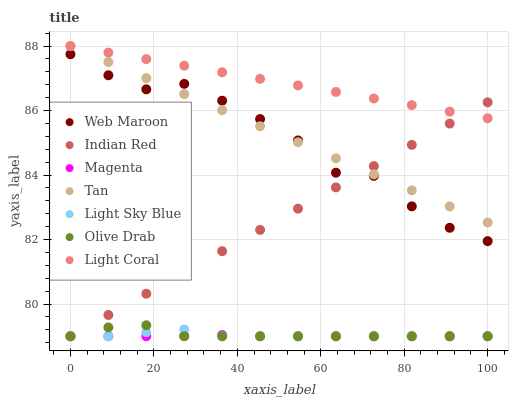Does Magenta have the minimum area under the curve?
Answer yes or no. Yes. Does Light Coral have the maximum area under the curve?
Answer yes or no. Yes. Does Light Sky Blue have the minimum area under the curve?
Answer yes or no. No. Does Light Sky Blue have the maximum area under the curve?
Answer yes or no. No. Is Light Coral the smoothest?
Answer yes or no. Yes. Is Web Maroon the roughest?
Answer yes or no. Yes. Is Light Sky Blue the smoothest?
Answer yes or no. No. Is Light Sky Blue the roughest?
Answer yes or no. No. Does Light Sky Blue have the lowest value?
Answer yes or no. Yes. Does Light Coral have the lowest value?
Answer yes or no. No. Does Tan have the highest value?
Answer yes or no. Yes. Does Light Sky Blue have the highest value?
Answer yes or no. No. Is Olive Drab less than Light Coral?
Answer yes or no. Yes. Is Web Maroon greater than Light Sky Blue?
Answer yes or no. Yes. Does Web Maroon intersect Indian Red?
Answer yes or no. Yes. Is Web Maroon less than Indian Red?
Answer yes or no. No. Is Web Maroon greater than Indian Red?
Answer yes or no. No. Does Olive Drab intersect Light Coral?
Answer yes or no. No. 